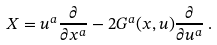<formula> <loc_0><loc_0><loc_500><loc_500>X = u ^ { a } \frac { \partial } { \partial x ^ { a } } - 2 G ^ { a } ( x , u ) \frac { \partial } { \partial u ^ { a } } \, .</formula> 